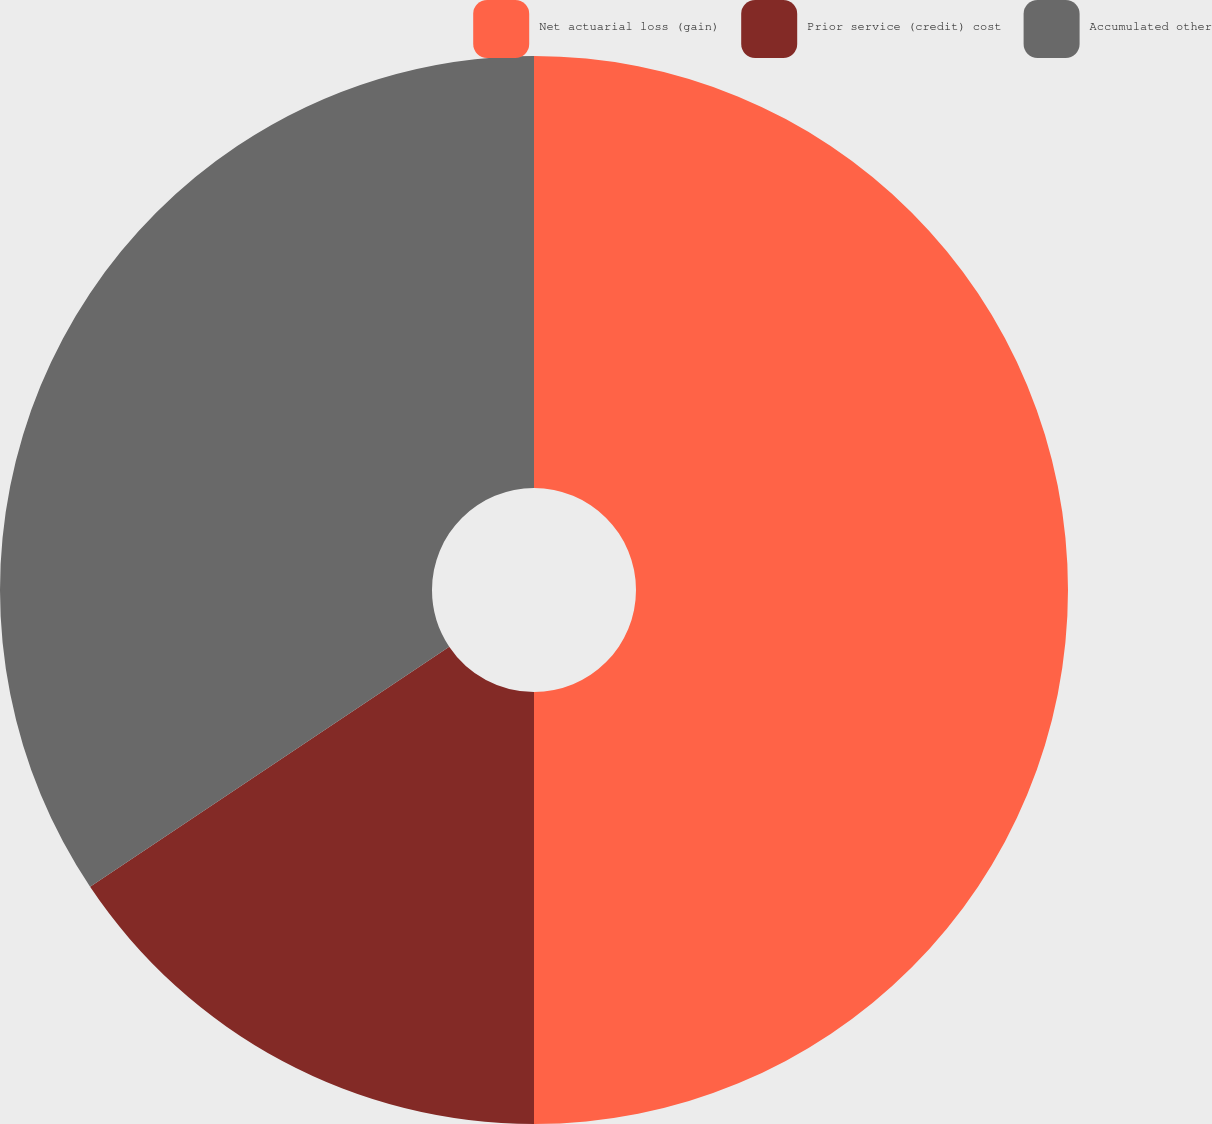Convert chart to OTSL. <chart><loc_0><loc_0><loc_500><loc_500><pie_chart><fcel>Net actuarial loss (gain)<fcel>Prior service (credit) cost<fcel>Accumulated other<nl><fcel>50.0%<fcel>15.62%<fcel>34.38%<nl></chart> 